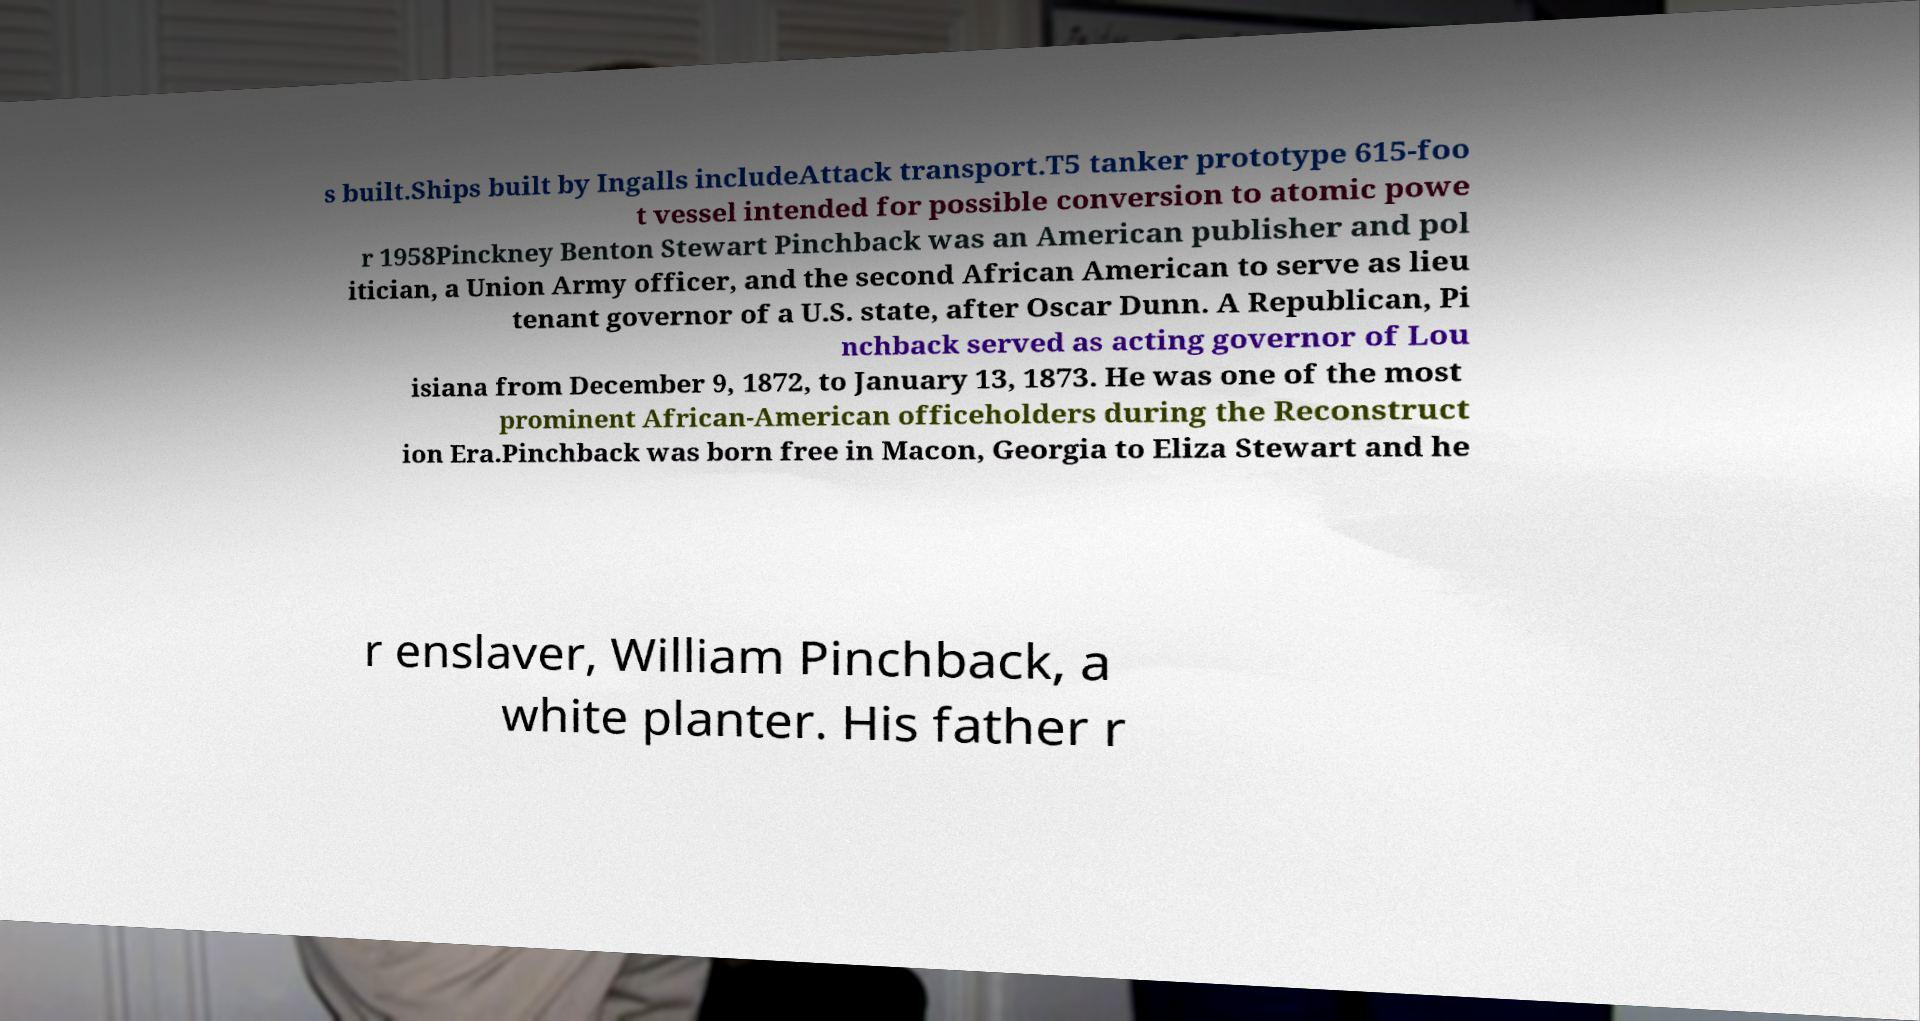What messages or text are displayed in this image? I need them in a readable, typed format. s built.Ships built by Ingalls includeAttack transport.T5 tanker prototype 615-foo t vessel intended for possible conversion to atomic powe r 1958Pinckney Benton Stewart Pinchback was an American publisher and pol itician, a Union Army officer, and the second African American to serve as lieu tenant governor of a U.S. state, after Oscar Dunn. A Republican, Pi nchback served as acting governor of Lou isiana from December 9, 1872, to January 13, 1873. He was one of the most prominent African-American officeholders during the Reconstruct ion Era.Pinchback was born free in Macon, Georgia to Eliza Stewart and he r enslaver, William Pinchback, a white planter. His father r 